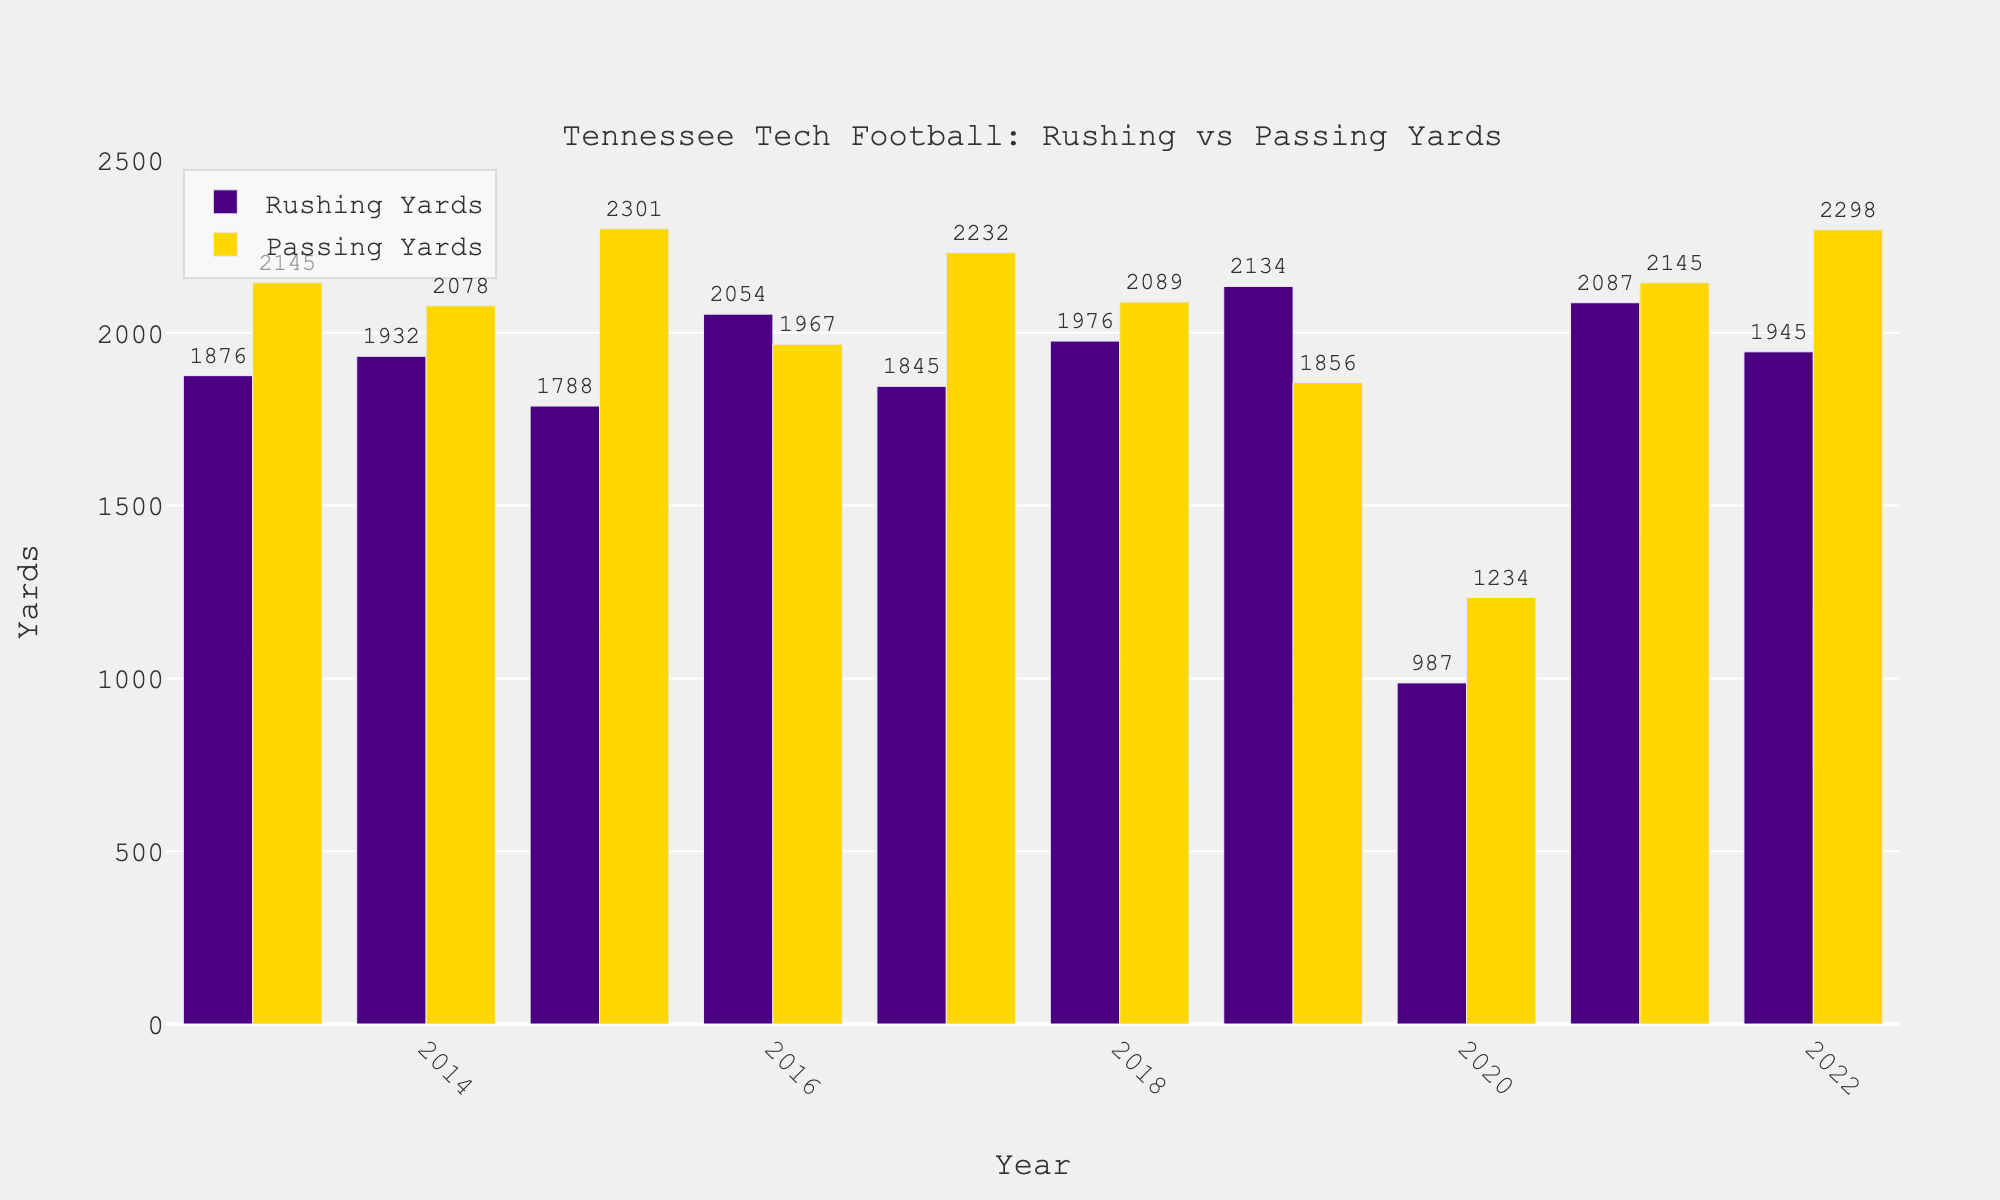Which year had the highest rushing yards? The year with the highest rushing yards can be identified by comparing the heights of the bars representing rushing yards. The tallest bar represents 2019 with 2,134 rushing yards.
Answer: 2019 What is the average rushing yards over the 10 years? To find the average rushing yards, sum up the rushing yards for all years and divide by 10. (1876 + 1932 + 1788 + 2054 + 1845 + 1976 + 2134 + 987 + 2087 + 1945) / 10 = 18,624 / 10 = 1,862.4
Answer: 1,862.4 Which year had the lowest passing yards? The year with the lowest passing yards can be identified by comparing the heights of the bars representing passing yards. The shortest bar represents 2020 with 1,234 passing yards.
Answer: 2020 Compare the rushing and passing yards in 2020. Which was greater and by how much? In 2020, the rushing yards were 987 and the passing yards were 1,234. To find the difference, subtract rushing yards from passing yards: 1,234 - 987 = 247.
Answer: Passing yards by 247 In how many years did passing yards exceed rushing yards? By visually comparing the heights of the bars for each year, passing yards exceeded rushing yards in 2013, 2014, 2015, 2017, 2018, 2020, and 2022.
Answer: 7 years What is the total rushing yards for all years combined? To find the total rushing yards, sum up the rushing yards for all years: 1876 + 1932 + 1788 + 2054 + 1845 + 1976 + 2134 + 987 + 2087 + 1945 = 18,624
Answer: 18,624 What is the difference between the total passing yards and the total rushing yards over the 10 years? Total passing yards = 2145 + 2078 + 2301 + 1967 + 2232 + 2089 + 1856 + 1234 + 2145 + 2298 = 20,345. Total rushing yards = 18,624. Difference = 20,345 - 18,624 = 1,721
Answer: 1,721 Which year saw the largest difference between rushing and passing yards? By calculating the difference for each year: 2013: 2145-1876 = 269, 2014: 2078-1932 = 146, 2015: 2301-1788 = 513, 2016: 2054-1967 = 87, 2017: 2232-1845 = 387, 2018: 2089-1976 = 113, 2019: 2134-1856 = 278, 2020: 1234-987 = 247, 2021: 2087-2145 = -58, 2022: 2298-1945 = 353. The largest difference is 513 in 2015.
Answer: 2015 